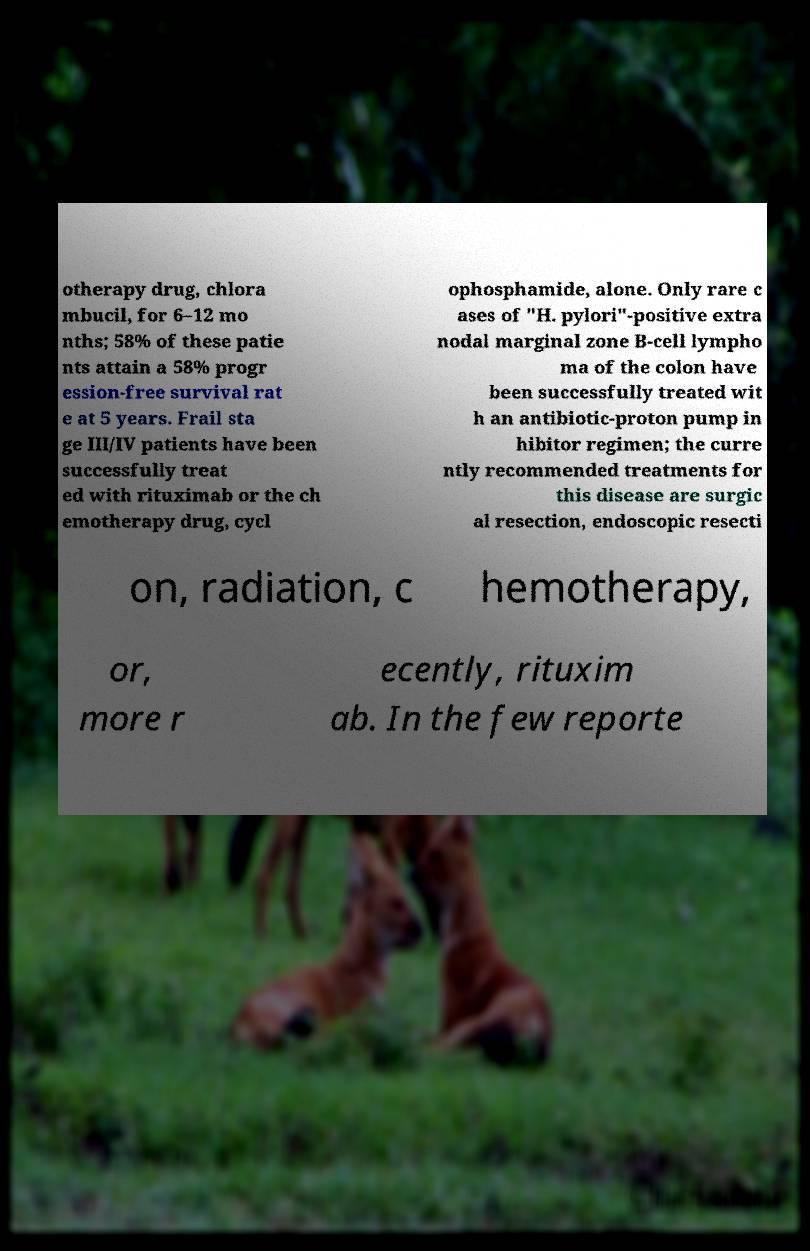Can you accurately transcribe the text from the provided image for me? otherapy drug, chlora mbucil, for 6–12 mo nths; 58% of these patie nts attain a 58% progr ession-free survival rat e at 5 years. Frail sta ge III/IV patients have been successfully treat ed with rituximab or the ch emotherapy drug, cycl ophosphamide, alone. Only rare c ases of "H. pylori"-positive extra nodal marginal zone B-cell lympho ma of the colon have been successfully treated wit h an antibiotic-proton pump in hibitor regimen; the curre ntly recommended treatments for this disease are surgic al resection, endoscopic resecti on, radiation, c hemotherapy, or, more r ecently, rituxim ab. In the few reporte 